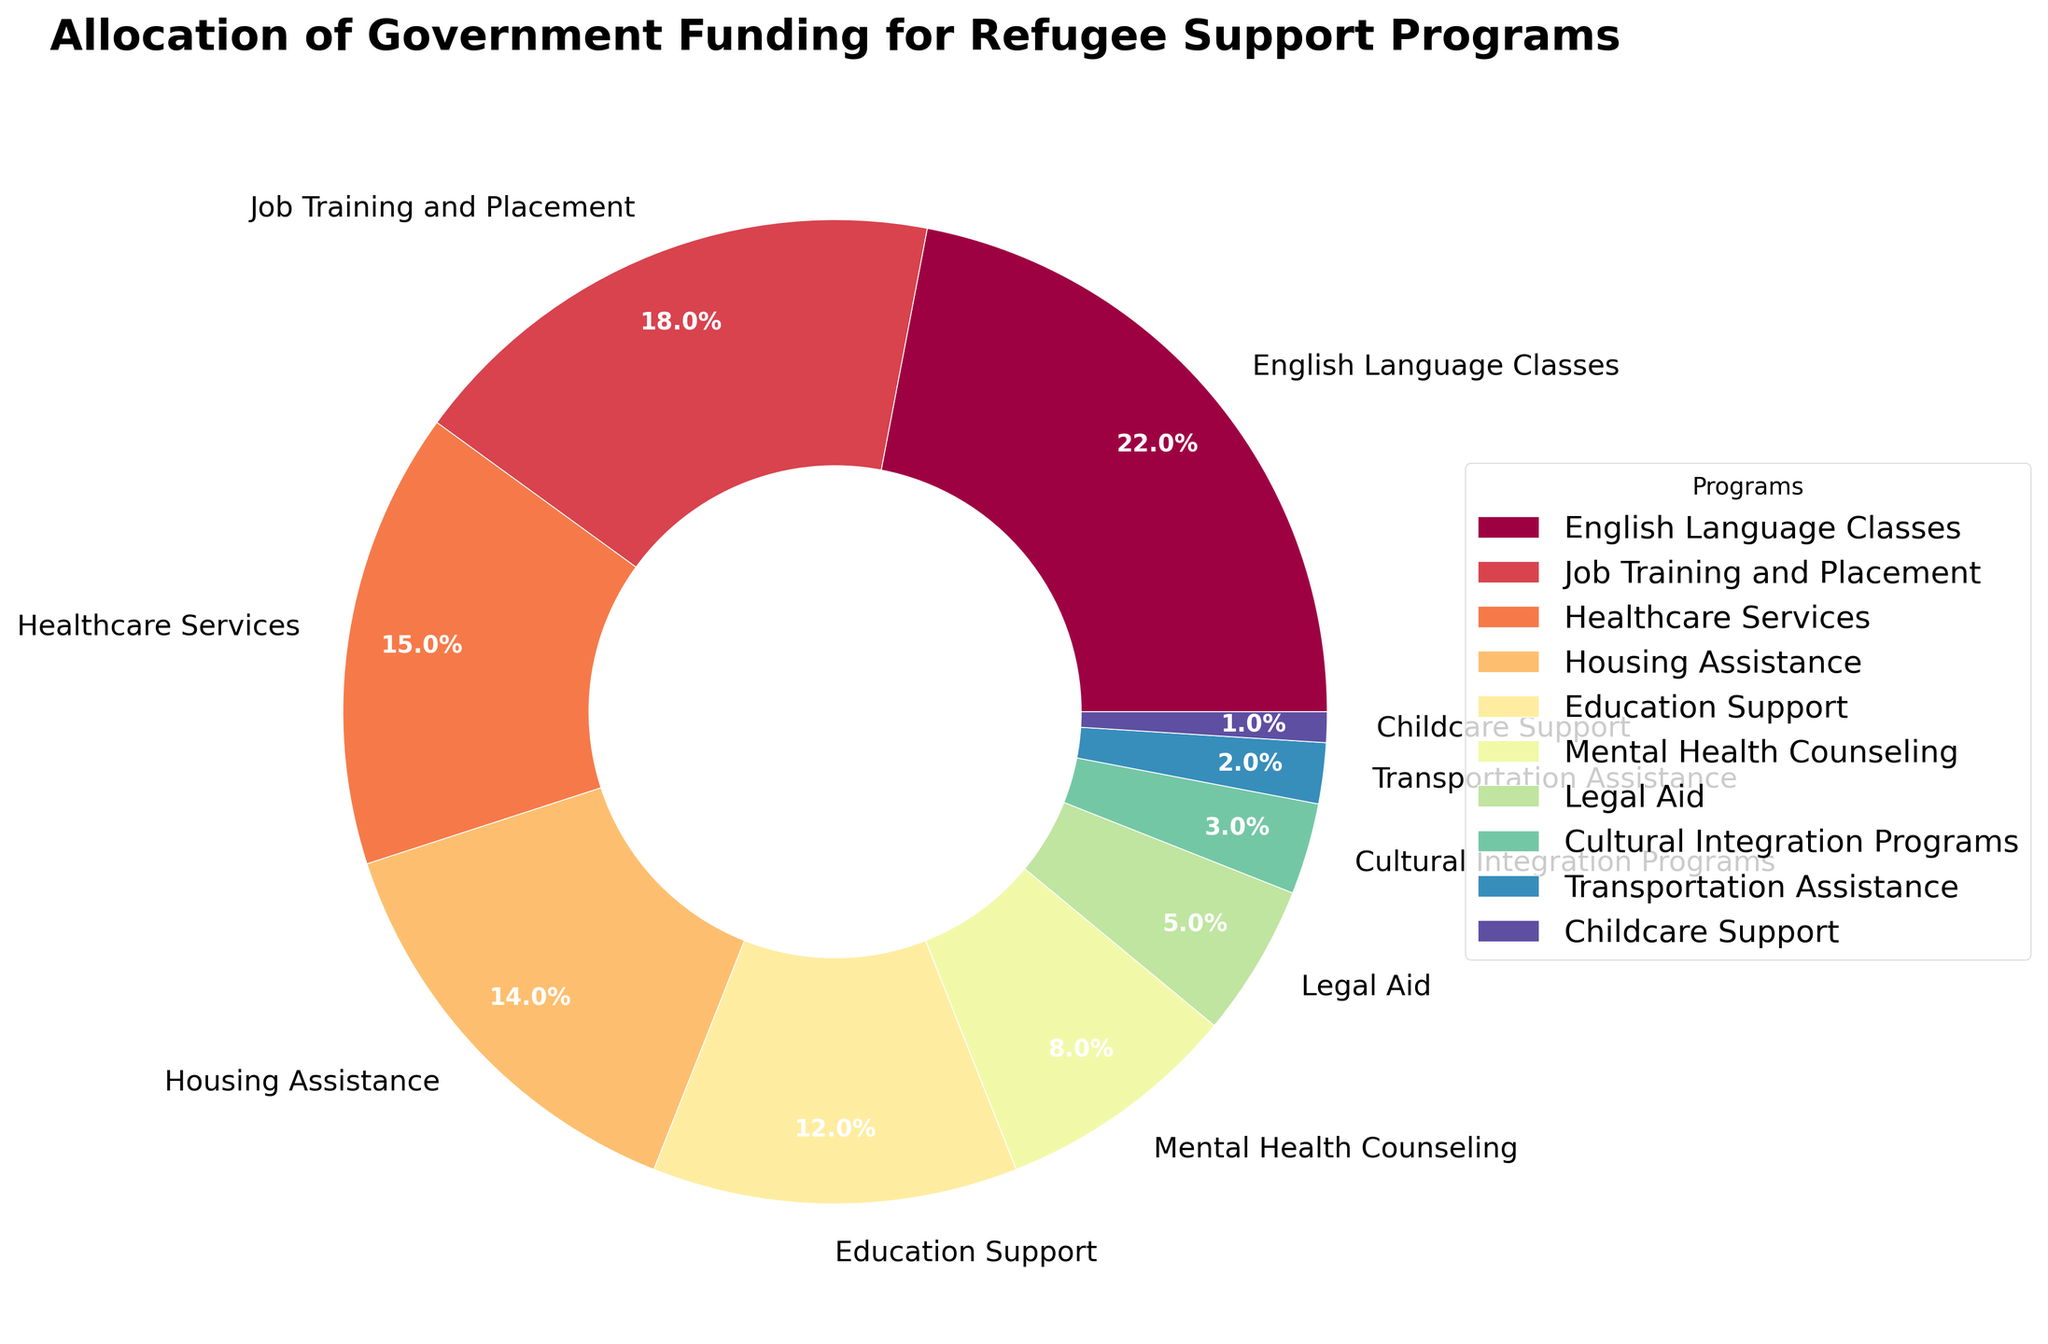What percentage of funding is allocated to Job Training and Placement programs? The chart indicates the various allocations with percentages labeled on the pie slices. Look for the label “Job Training and Placement” and read the corresponding percentage.
Answer: 18% Which program receives the least amount of funding and what is that percentage? Examine the pie chart for the smallest slice. Check the label next to this slice for the program name and its percentage.
Answer: Childcare Support, 1% Are there more funds allocated to Housing Assistance or Education Support? Identify the slices labeled “Housing Assistance” and “Education Support.” Compare the percentages written on these slices.
Answer: Housing Assistance What is the total percentage of funding allocated to Mental Health Counseling, Legal Aid, and Cultural Integration Programs combined? Sum up the percentages labeled for “Mental Health Counseling” (8%), “Legal Aid” (5%), and “Cultural Integration Programs” (3%). Calculation: 8 + 5 + 3.
Answer: 16% Which program receives the highest allocation and by how much more compared to Transportation Assistance? Find the slice with the highest percentage labeled (which is “English Language Classes” at 22%). Compare it with the percentage for “Transportation Assistance” (2%). Subtract the percentages: 22 - 2.
Answer: English Language Classes, 20% more How much more funding percentage does Healthcare Services get compared to Legal Aid? Identify the percentages for “Healthcare Services” (15%) and “Legal Aid” (5%). Subtract the smaller percentage from the larger one: 15 - 5.
Answer: 10% List the programs that receive less than 10% of the funding Examine the chart for the programs where the sliced percentages are below 10%.
Answer: Mental Health Counseling, Legal Aid, Cultural Integration Programs, Transportation Assistance, Childcare Support What is the combined funding allocation percentage for Healthcare Services and Housing Assistance? Add the percentages for “Healthcare Services” (15%) and “Housing Assistance” (14%). Calculation: 15 + 14.
Answer: 29% Are Legal Aid and Cultural Integration Programs colored differently in the chart? Observe the slices labeled “Legal Aid” and “Cultural Integration Programs.” Each slice should be a different color in the pie chart.
Answer: Yes 